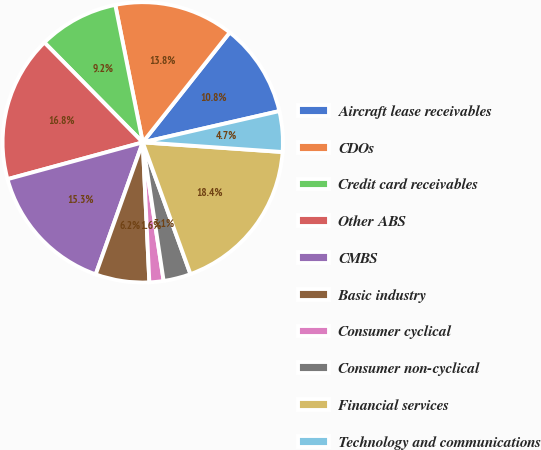<chart> <loc_0><loc_0><loc_500><loc_500><pie_chart><fcel>Aircraft lease receivables<fcel>CDOs<fcel>Credit card receivables<fcel>Other ABS<fcel>CMBS<fcel>Basic industry<fcel>Consumer cyclical<fcel>Consumer non-cyclical<fcel>Financial services<fcel>Technology and communications<nl><fcel>10.76%<fcel>13.8%<fcel>9.24%<fcel>16.85%<fcel>15.32%<fcel>6.2%<fcel>1.63%<fcel>3.15%<fcel>18.37%<fcel>4.68%<nl></chart> 